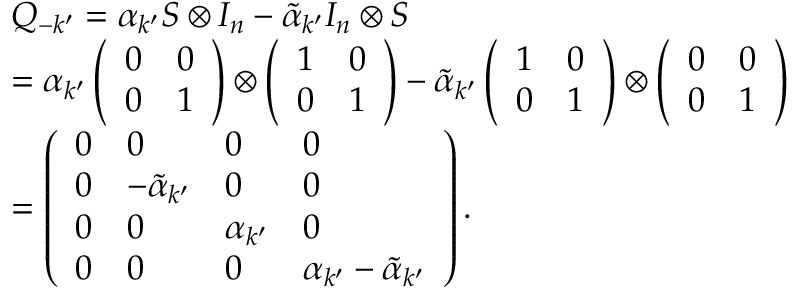<formula> <loc_0><loc_0><loc_500><loc_500>\begin{array} { r l } & { { { Q } _ { - k ^ { \prime } } } = { { \alpha } _ { k ^ { \prime } } } { S } \otimes { { I } _ { n } } - { { { \tilde { \alpha } } } _ { k ^ { \prime } } } { { I } _ { n } } \otimes { S } } \\ & { = { { \alpha } _ { k ^ { \prime } } } \left ( \begin{array} { l l } { 0 } & { 0 } \\ { 0 } & { 1 } \end{array} \right ) \otimes \left ( \begin{array} { l l } { 1 } & { 0 } \\ { 0 } & { 1 } \end{array} \right ) - { { { \tilde { \alpha } } } _ { k ^ { \prime } } } \left ( \begin{array} { l l } { 1 } & { 0 } \\ { 0 } & { 1 } \end{array} \right ) \otimes \left ( \begin{array} { l l } { 0 } & { 0 } \\ { 0 } & { 1 } \end{array} \right ) } \\ & { = \left ( \begin{array} { l l l l } { 0 } & { 0 } & { 0 } & { 0 } \\ { 0 } & { { { { - \tilde { \alpha } } } _ { k ^ { \prime } } } } & { 0 } & { 0 } \\ { 0 } & { 0 } & { { { \alpha } _ { k ^ { \prime } } } } & { 0 } \\ { 0 } & { 0 } & { 0 } & { { { \alpha } _ { k ^ { \prime } } } - { { { \tilde { \alpha } } } _ { k ^ { \prime } } } } \end{array} \right ) . } \end{array}</formula> 